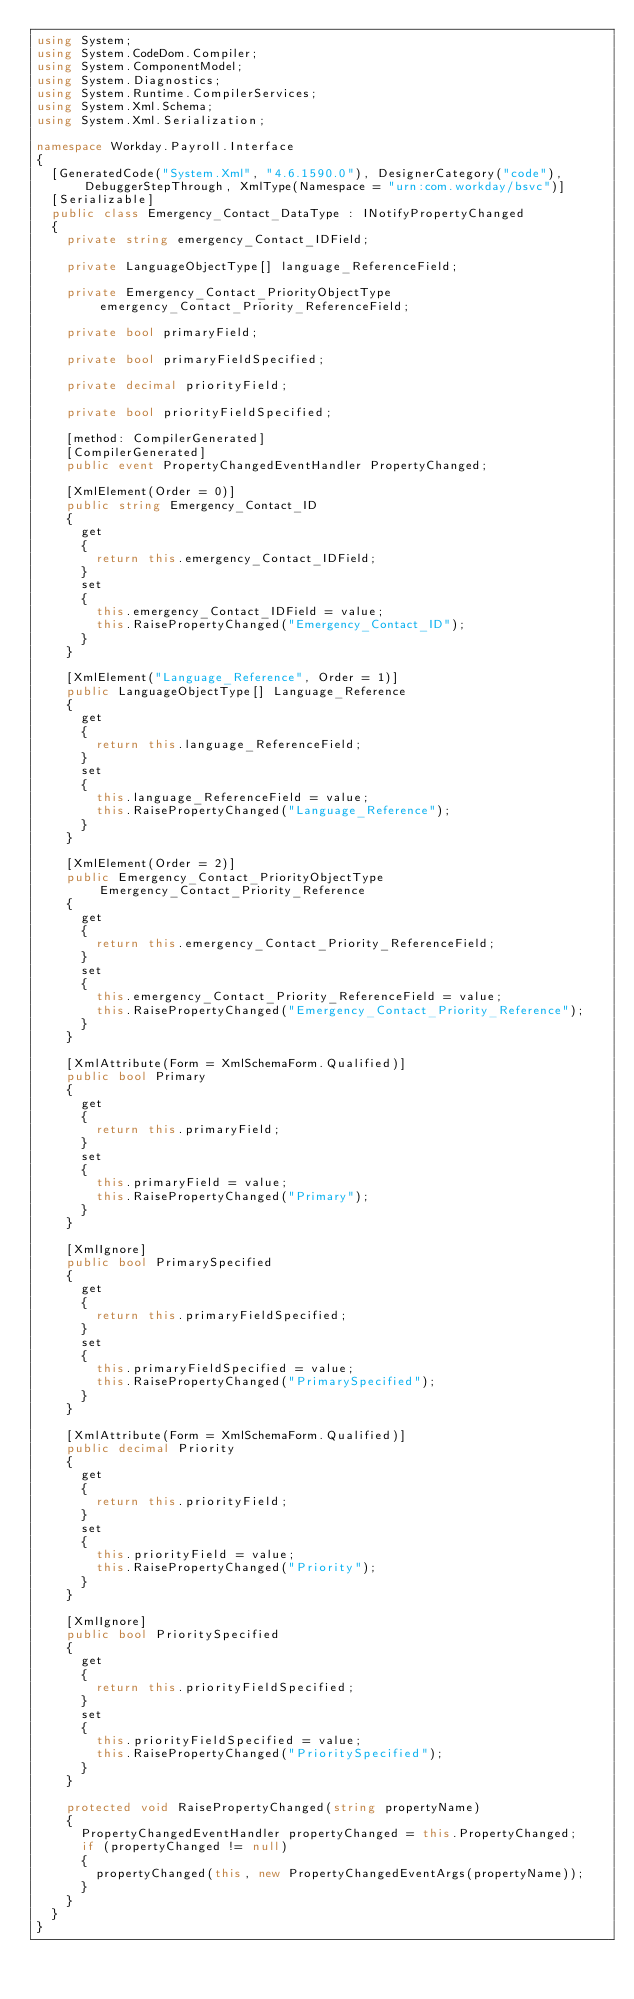Convert code to text. <code><loc_0><loc_0><loc_500><loc_500><_C#_>using System;
using System.CodeDom.Compiler;
using System.ComponentModel;
using System.Diagnostics;
using System.Runtime.CompilerServices;
using System.Xml.Schema;
using System.Xml.Serialization;

namespace Workday.Payroll.Interface
{
	[GeneratedCode("System.Xml", "4.6.1590.0"), DesignerCategory("code"), DebuggerStepThrough, XmlType(Namespace = "urn:com.workday/bsvc")]
	[Serializable]
	public class Emergency_Contact_DataType : INotifyPropertyChanged
	{
		private string emergency_Contact_IDField;

		private LanguageObjectType[] language_ReferenceField;

		private Emergency_Contact_PriorityObjectType emergency_Contact_Priority_ReferenceField;

		private bool primaryField;

		private bool primaryFieldSpecified;

		private decimal priorityField;

		private bool priorityFieldSpecified;

		[method: CompilerGenerated]
		[CompilerGenerated]
		public event PropertyChangedEventHandler PropertyChanged;

		[XmlElement(Order = 0)]
		public string Emergency_Contact_ID
		{
			get
			{
				return this.emergency_Contact_IDField;
			}
			set
			{
				this.emergency_Contact_IDField = value;
				this.RaisePropertyChanged("Emergency_Contact_ID");
			}
		}

		[XmlElement("Language_Reference", Order = 1)]
		public LanguageObjectType[] Language_Reference
		{
			get
			{
				return this.language_ReferenceField;
			}
			set
			{
				this.language_ReferenceField = value;
				this.RaisePropertyChanged("Language_Reference");
			}
		}

		[XmlElement(Order = 2)]
		public Emergency_Contact_PriorityObjectType Emergency_Contact_Priority_Reference
		{
			get
			{
				return this.emergency_Contact_Priority_ReferenceField;
			}
			set
			{
				this.emergency_Contact_Priority_ReferenceField = value;
				this.RaisePropertyChanged("Emergency_Contact_Priority_Reference");
			}
		}

		[XmlAttribute(Form = XmlSchemaForm.Qualified)]
		public bool Primary
		{
			get
			{
				return this.primaryField;
			}
			set
			{
				this.primaryField = value;
				this.RaisePropertyChanged("Primary");
			}
		}

		[XmlIgnore]
		public bool PrimarySpecified
		{
			get
			{
				return this.primaryFieldSpecified;
			}
			set
			{
				this.primaryFieldSpecified = value;
				this.RaisePropertyChanged("PrimarySpecified");
			}
		}

		[XmlAttribute(Form = XmlSchemaForm.Qualified)]
		public decimal Priority
		{
			get
			{
				return this.priorityField;
			}
			set
			{
				this.priorityField = value;
				this.RaisePropertyChanged("Priority");
			}
		}

		[XmlIgnore]
		public bool PrioritySpecified
		{
			get
			{
				return this.priorityFieldSpecified;
			}
			set
			{
				this.priorityFieldSpecified = value;
				this.RaisePropertyChanged("PrioritySpecified");
			}
		}

		protected void RaisePropertyChanged(string propertyName)
		{
			PropertyChangedEventHandler propertyChanged = this.PropertyChanged;
			if (propertyChanged != null)
			{
				propertyChanged(this, new PropertyChangedEventArgs(propertyName));
			}
		}
	}
}
</code> 